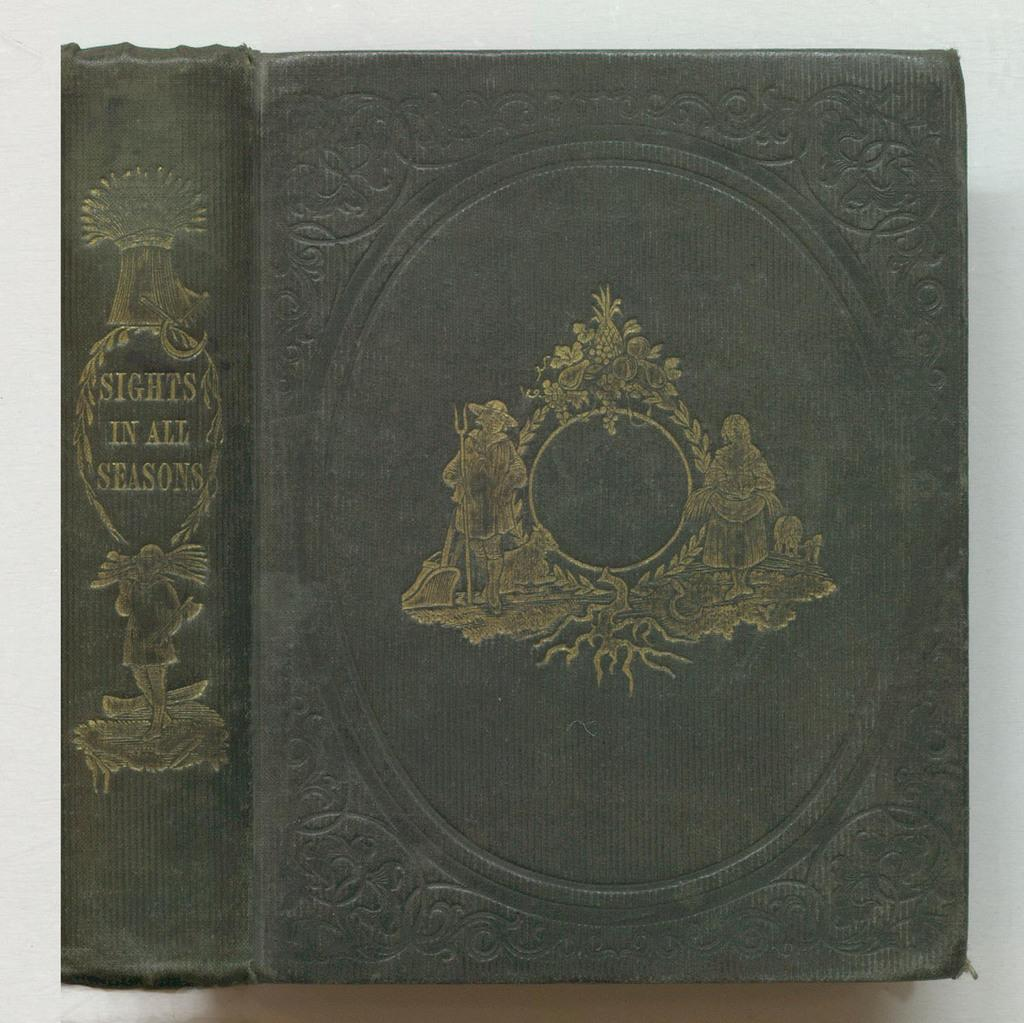Provide a one-sentence caption for the provided image. a book that is called 'sights in all seasons'. 